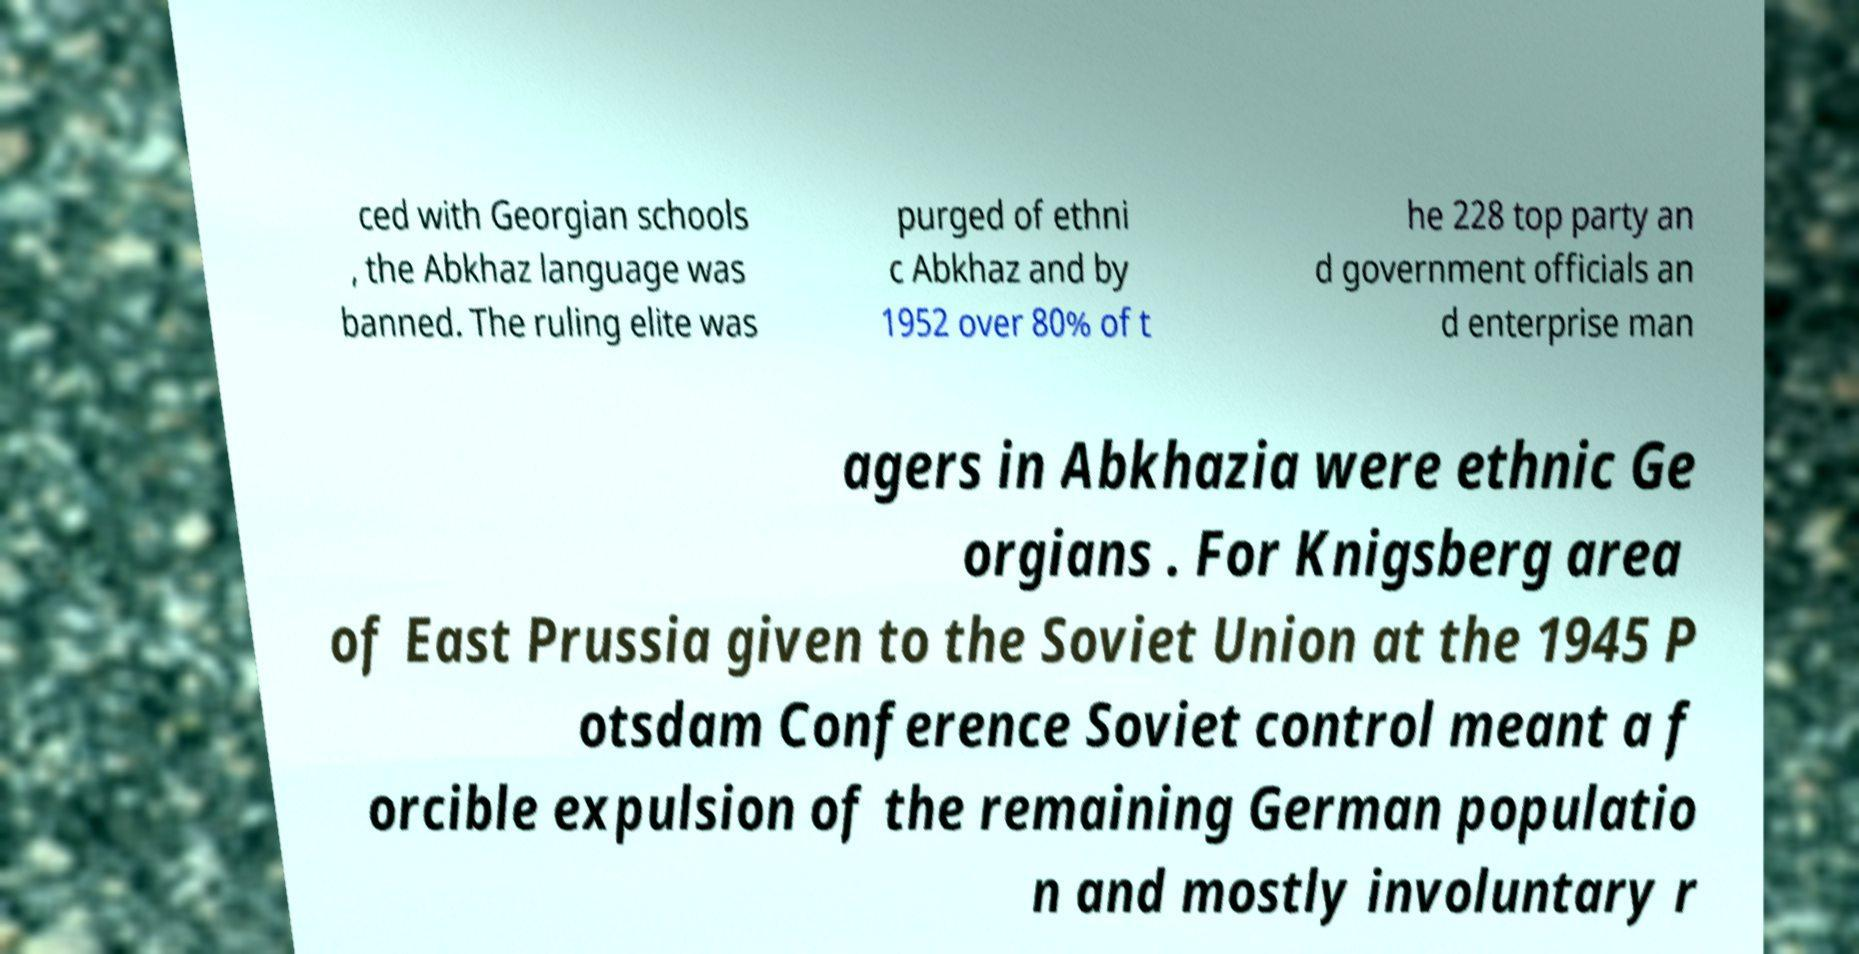There's text embedded in this image that I need extracted. Can you transcribe it verbatim? ced with Georgian schools , the Abkhaz language was banned. The ruling elite was purged of ethni c Abkhaz and by 1952 over 80% of t he 228 top party an d government officials an d enterprise man agers in Abkhazia were ethnic Ge orgians . For Knigsberg area of East Prussia given to the Soviet Union at the 1945 P otsdam Conference Soviet control meant a f orcible expulsion of the remaining German populatio n and mostly involuntary r 